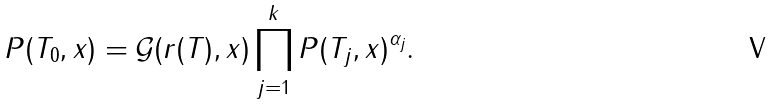Convert formula to latex. <formula><loc_0><loc_0><loc_500><loc_500>P ( T _ { 0 } , x ) & = \mathcal { G } ( r ( T ) , x ) \prod _ { j = 1 } ^ { k } P ( T _ { j } , x ) ^ { \alpha _ { j } } .</formula> 